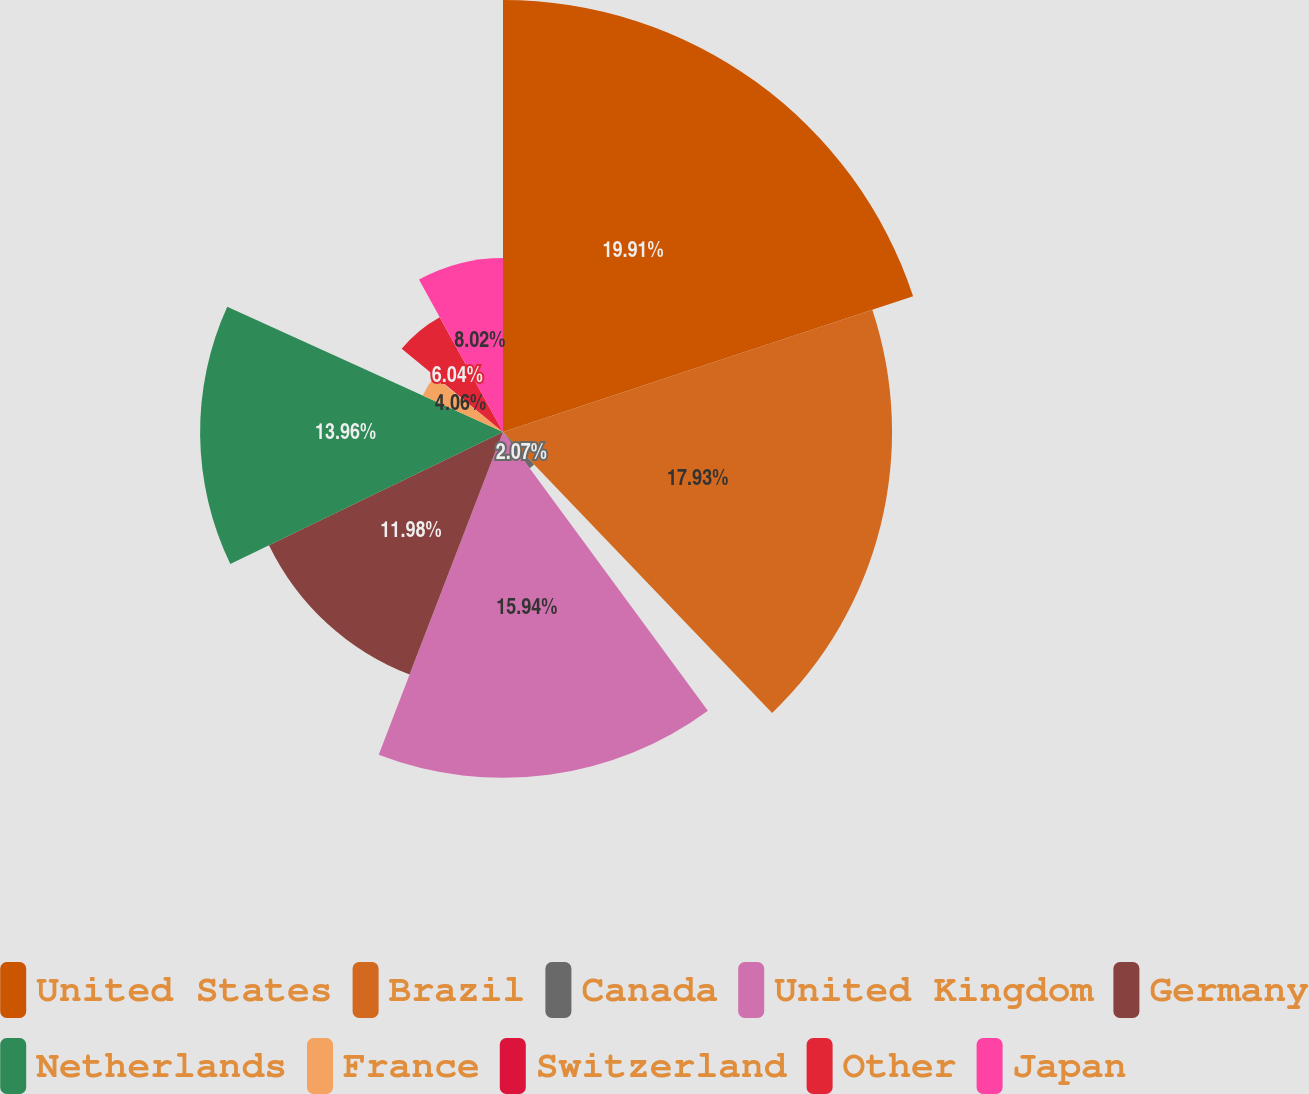Convert chart to OTSL. <chart><loc_0><loc_0><loc_500><loc_500><pie_chart><fcel>United States<fcel>Brazil<fcel>Canada<fcel>United Kingdom<fcel>Germany<fcel>Netherlands<fcel>France<fcel>Switzerland<fcel>Other<fcel>Japan<nl><fcel>19.91%<fcel>17.93%<fcel>2.07%<fcel>15.94%<fcel>11.98%<fcel>13.96%<fcel>4.06%<fcel>0.09%<fcel>6.04%<fcel>8.02%<nl></chart> 